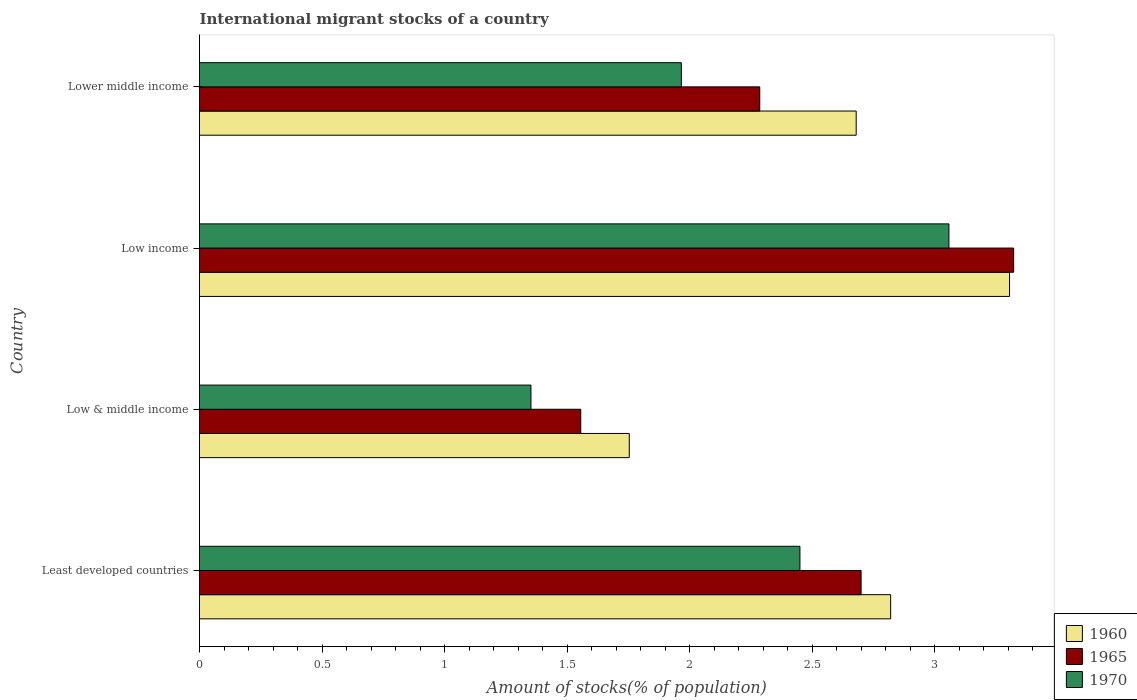How many different coloured bars are there?
Your answer should be very brief. 3. Are the number of bars per tick equal to the number of legend labels?
Your response must be concise. Yes. How many bars are there on the 4th tick from the bottom?
Give a very brief answer. 3. What is the label of the 1st group of bars from the top?
Provide a short and direct response. Lower middle income. What is the amount of stocks in in 1960 in Least developed countries?
Offer a terse response. 2.82. Across all countries, what is the maximum amount of stocks in in 1965?
Make the answer very short. 3.32. Across all countries, what is the minimum amount of stocks in in 1960?
Provide a short and direct response. 1.75. In which country was the amount of stocks in in 1965 maximum?
Provide a short and direct response. Low income. In which country was the amount of stocks in in 1970 minimum?
Your answer should be compact. Low & middle income. What is the total amount of stocks in in 1960 in the graph?
Provide a short and direct response. 10.56. What is the difference between the amount of stocks in in 1965 in Low & middle income and that in Lower middle income?
Offer a very short reply. -0.73. What is the difference between the amount of stocks in in 1960 in Lower middle income and the amount of stocks in in 1965 in Low & middle income?
Offer a terse response. 1.12. What is the average amount of stocks in in 1960 per country?
Offer a terse response. 2.64. What is the difference between the amount of stocks in in 1965 and amount of stocks in in 1970 in Low & middle income?
Provide a succinct answer. 0.2. What is the ratio of the amount of stocks in in 1960 in Low & middle income to that in Lower middle income?
Your answer should be very brief. 0.65. Is the amount of stocks in in 1960 in Low & middle income less than that in Low income?
Your response must be concise. Yes. What is the difference between the highest and the second highest amount of stocks in in 1970?
Your answer should be compact. 0.61. What is the difference between the highest and the lowest amount of stocks in in 1960?
Provide a short and direct response. 1.55. Is the sum of the amount of stocks in in 1970 in Least developed countries and Low & middle income greater than the maximum amount of stocks in in 1965 across all countries?
Provide a short and direct response. Yes. What does the 2nd bar from the top in Least developed countries represents?
Offer a terse response. 1965. What does the 2nd bar from the bottom in Least developed countries represents?
Offer a very short reply. 1965. Is it the case that in every country, the sum of the amount of stocks in in 1965 and amount of stocks in in 1960 is greater than the amount of stocks in in 1970?
Ensure brevity in your answer.  Yes. Are all the bars in the graph horizontal?
Make the answer very short. Yes. How many countries are there in the graph?
Offer a very short reply. 4. What is the difference between two consecutive major ticks on the X-axis?
Your answer should be compact. 0.5. Are the values on the major ticks of X-axis written in scientific E-notation?
Keep it short and to the point. No. Does the graph contain any zero values?
Give a very brief answer. No. Does the graph contain grids?
Keep it short and to the point. No. How are the legend labels stacked?
Your response must be concise. Vertical. What is the title of the graph?
Provide a short and direct response. International migrant stocks of a country. What is the label or title of the X-axis?
Your answer should be very brief. Amount of stocks(% of population). What is the Amount of stocks(% of population) in 1960 in Least developed countries?
Provide a succinct answer. 2.82. What is the Amount of stocks(% of population) in 1965 in Least developed countries?
Provide a short and direct response. 2.7. What is the Amount of stocks(% of population) of 1970 in Least developed countries?
Provide a succinct answer. 2.45. What is the Amount of stocks(% of population) in 1960 in Low & middle income?
Give a very brief answer. 1.75. What is the Amount of stocks(% of population) of 1965 in Low & middle income?
Give a very brief answer. 1.56. What is the Amount of stocks(% of population) in 1970 in Low & middle income?
Your answer should be compact. 1.35. What is the Amount of stocks(% of population) of 1960 in Low income?
Your answer should be very brief. 3.31. What is the Amount of stocks(% of population) in 1965 in Low income?
Keep it short and to the point. 3.32. What is the Amount of stocks(% of population) in 1970 in Low income?
Your answer should be very brief. 3.06. What is the Amount of stocks(% of population) of 1960 in Lower middle income?
Keep it short and to the point. 2.68. What is the Amount of stocks(% of population) of 1965 in Lower middle income?
Ensure brevity in your answer.  2.29. What is the Amount of stocks(% of population) of 1970 in Lower middle income?
Provide a short and direct response. 1.97. Across all countries, what is the maximum Amount of stocks(% of population) in 1960?
Your answer should be very brief. 3.31. Across all countries, what is the maximum Amount of stocks(% of population) of 1965?
Offer a terse response. 3.32. Across all countries, what is the maximum Amount of stocks(% of population) in 1970?
Offer a terse response. 3.06. Across all countries, what is the minimum Amount of stocks(% of population) in 1960?
Give a very brief answer. 1.75. Across all countries, what is the minimum Amount of stocks(% of population) of 1965?
Provide a succinct answer. 1.56. Across all countries, what is the minimum Amount of stocks(% of population) in 1970?
Offer a terse response. 1.35. What is the total Amount of stocks(% of population) in 1960 in the graph?
Offer a terse response. 10.56. What is the total Amount of stocks(% of population) in 1965 in the graph?
Offer a very short reply. 9.86. What is the total Amount of stocks(% of population) in 1970 in the graph?
Give a very brief answer. 8.83. What is the difference between the Amount of stocks(% of population) in 1960 in Least developed countries and that in Low & middle income?
Keep it short and to the point. 1.07. What is the difference between the Amount of stocks(% of population) of 1965 in Least developed countries and that in Low & middle income?
Make the answer very short. 1.14. What is the difference between the Amount of stocks(% of population) in 1970 in Least developed countries and that in Low & middle income?
Give a very brief answer. 1.1. What is the difference between the Amount of stocks(% of population) in 1960 in Least developed countries and that in Low income?
Provide a short and direct response. -0.49. What is the difference between the Amount of stocks(% of population) of 1965 in Least developed countries and that in Low income?
Offer a terse response. -0.62. What is the difference between the Amount of stocks(% of population) in 1970 in Least developed countries and that in Low income?
Your response must be concise. -0.61. What is the difference between the Amount of stocks(% of population) in 1960 in Least developed countries and that in Lower middle income?
Ensure brevity in your answer.  0.14. What is the difference between the Amount of stocks(% of population) of 1965 in Least developed countries and that in Lower middle income?
Offer a terse response. 0.41. What is the difference between the Amount of stocks(% of population) of 1970 in Least developed countries and that in Lower middle income?
Your response must be concise. 0.48. What is the difference between the Amount of stocks(% of population) in 1960 in Low & middle income and that in Low income?
Your response must be concise. -1.55. What is the difference between the Amount of stocks(% of population) of 1965 in Low & middle income and that in Low income?
Give a very brief answer. -1.77. What is the difference between the Amount of stocks(% of population) of 1970 in Low & middle income and that in Low income?
Ensure brevity in your answer.  -1.71. What is the difference between the Amount of stocks(% of population) in 1960 in Low & middle income and that in Lower middle income?
Offer a terse response. -0.93. What is the difference between the Amount of stocks(% of population) in 1965 in Low & middle income and that in Lower middle income?
Provide a short and direct response. -0.73. What is the difference between the Amount of stocks(% of population) of 1970 in Low & middle income and that in Lower middle income?
Your answer should be very brief. -0.61. What is the difference between the Amount of stocks(% of population) of 1960 in Low income and that in Lower middle income?
Your answer should be very brief. 0.63. What is the difference between the Amount of stocks(% of population) of 1965 in Low income and that in Lower middle income?
Keep it short and to the point. 1.04. What is the difference between the Amount of stocks(% of population) of 1970 in Low income and that in Lower middle income?
Your response must be concise. 1.09. What is the difference between the Amount of stocks(% of population) in 1960 in Least developed countries and the Amount of stocks(% of population) in 1965 in Low & middle income?
Provide a succinct answer. 1.26. What is the difference between the Amount of stocks(% of population) in 1960 in Least developed countries and the Amount of stocks(% of population) in 1970 in Low & middle income?
Make the answer very short. 1.47. What is the difference between the Amount of stocks(% of population) in 1965 in Least developed countries and the Amount of stocks(% of population) in 1970 in Low & middle income?
Provide a short and direct response. 1.35. What is the difference between the Amount of stocks(% of population) in 1960 in Least developed countries and the Amount of stocks(% of population) in 1965 in Low income?
Ensure brevity in your answer.  -0.5. What is the difference between the Amount of stocks(% of population) of 1960 in Least developed countries and the Amount of stocks(% of population) of 1970 in Low income?
Give a very brief answer. -0.24. What is the difference between the Amount of stocks(% of population) of 1965 in Least developed countries and the Amount of stocks(% of population) of 1970 in Low income?
Provide a short and direct response. -0.36. What is the difference between the Amount of stocks(% of population) of 1960 in Least developed countries and the Amount of stocks(% of population) of 1965 in Lower middle income?
Provide a short and direct response. 0.53. What is the difference between the Amount of stocks(% of population) in 1960 in Least developed countries and the Amount of stocks(% of population) in 1970 in Lower middle income?
Your answer should be very brief. 0.85. What is the difference between the Amount of stocks(% of population) of 1965 in Least developed countries and the Amount of stocks(% of population) of 1970 in Lower middle income?
Offer a very short reply. 0.73. What is the difference between the Amount of stocks(% of population) of 1960 in Low & middle income and the Amount of stocks(% of population) of 1965 in Low income?
Make the answer very short. -1.57. What is the difference between the Amount of stocks(% of population) of 1960 in Low & middle income and the Amount of stocks(% of population) of 1970 in Low income?
Your answer should be compact. -1.3. What is the difference between the Amount of stocks(% of population) of 1965 in Low & middle income and the Amount of stocks(% of population) of 1970 in Low income?
Your answer should be compact. -1.5. What is the difference between the Amount of stocks(% of population) in 1960 in Low & middle income and the Amount of stocks(% of population) in 1965 in Lower middle income?
Your answer should be very brief. -0.53. What is the difference between the Amount of stocks(% of population) in 1960 in Low & middle income and the Amount of stocks(% of population) in 1970 in Lower middle income?
Give a very brief answer. -0.21. What is the difference between the Amount of stocks(% of population) in 1965 in Low & middle income and the Amount of stocks(% of population) in 1970 in Lower middle income?
Your answer should be compact. -0.41. What is the difference between the Amount of stocks(% of population) in 1960 in Low income and the Amount of stocks(% of population) in 1965 in Lower middle income?
Your answer should be compact. 1.02. What is the difference between the Amount of stocks(% of population) in 1960 in Low income and the Amount of stocks(% of population) in 1970 in Lower middle income?
Give a very brief answer. 1.34. What is the difference between the Amount of stocks(% of population) in 1965 in Low income and the Amount of stocks(% of population) in 1970 in Lower middle income?
Your answer should be compact. 1.36. What is the average Amount of stocks(% of population) of 1960 per country?
Keep it short and to the point. 2.64. What is the average Amount of stocks(% of population) in 1965 per country?
Make the answer very short. 2.47. What is the average Amount of stocks(% of population) in 1970 per country?
Offer a terse response. 2.21. What is the difference between the Amount of stocks(% of population) in 1960 and Amount of stocks(% of population) in 1965 in Least developed countries?
Make the answer very short. 0.12. What is the difference between the Amount of stocks(% of population) in 1960 and Amount of stocks(% of population) in 1970 in Least developed countries?
Your answer should be very brief. 0.37. What is the difference between the Amount of stocks(% of population) in 1965 and Amount of stocks(% of population) in 1970 in Least developed countries?
Offer a very short reply. 0.25. What is the difference between the Amount of stocks(% of population) of 1960 and Amount of stocks(% of population) of 1965 in Low & middle income?
Offer a very short reply. 0.2. What is the difference between the Amount of stocks(% of population) of 1960 and Amount of stocks(% of population) of 1970 in Low & middle income?
Your answer should be compact. 0.4. What is the difference between the Amount of stocks(% of population) in 1965 and Amount of stocks(% of population) in 1970 in Low & middle income?
Your answer should be very brief. 0.2. What is the difference between the Amount of stocks(% of population) of 1960 and Amount of stocks(% of population) of 1965 in Low income?
Your answer should be very brief. -0.02. What is the difference between the Amount of stocks(% of population) in 1960 and Amount of stocks(% of population) in 1970 in Low income?
Offer a terse response. 0.25. What is the difference between the Amount of stocks(% of population) of 1965 and Amount of stocks(% of population) of 1970 in Low income?
Offer a very short reply. 0.26. What is the difference between the Amount of stocks(% of population) of 1960 and Amount of stocks(% of population) of 1965 in Lower middle income?
Offer a terse response. 0.39. What is the difference between the Amount of stocks(% of population) in 1960 and Amount of stocks(% of population) in 1970 in Lower middle income?
Ensure brevity in your answer.  0.71. What is the difference between the Amount of stocks(% of population) in 1965 and Amount of stocks(% of population) in 1970 in Lower middle income?
Offer a terse response. 0.32. What is the ratio of the Amount of stocks(% of population) of 1960 in Least developed countries to that in Low & middle income?
Your answer should be compact. 1.61. What is the ratio of the Amount of stocks(% of population) in 1965 in Least developed countries to that in Low & middle income?
Ensure brevity in your answer.  1.74. What is the ratio of the Amount of stocks(% of population) in 1970 in Least developed countries to that in Low & middle income?
Make the answer very short. 1.81. What is the ratio of the Amount of stocks(% of population) in 1960 in Least developed countries to that in Low income?
Ensure brevity in your answer.  0.85. What is the ratio of the Amount of stocks(% of population) in 1965 in Least developed countries to that in Low income?
Offer a terse response. 0.81. What is the ratio of the Amount of stocks(% of population) of 1970 in Least developed countries to that in Low income?
Keep it short and to the point. 0.8. What is the ratio of the Amount of stocks(% of population) in 1960 in Least developed countries to that in Lower middle income?
Offer a very short reply. 1.05. What is the ratio of the Amount of stocks(% of population) in 1965 in Least developed countries to that in Lower middle income?
Ensure brevity in your answer.  1.18. What is the ratio of the Amount of stocks(% of population) of 1970 in Least developed countries to that in Lower middle income?
Offer a very short reply. 1.25. What is the ratio of the Amount of stocks(% of population) in 1960 in Low & middle income to that in Low income?
Ensure brevity in your answer.  0.53. What is the ratio of the Amount of stocks(% of population) of 1965 in Low & middle income to that in Low income?
Keep it short and to the point. 0.47. What is the ratio of the Amount of stocks(% of population) of 1970 in Low & middle income to that in Low income?
Keep it short and to the point. 0.44. What is the ratio of the Amount of stocks(% of population) of 1960 in Low & middle income to that in Lower middle income?
Your answer should be compact. 0.65. What is the ratio of the Amount of stocks(% of population) in 1965 in Low & middle income to that in Lower middle income?
Provide a short and direct response. 0.68. What is the ratio of the Amount of stocks(% of population) of 1970 in Low & middle income to that in Lower middle income?
Ensure brevity in your answer.  0.69. What is the ratio of the Amount of stocks(% of population) in 1960 in Low income to that in Lower middle income?
Keep it short and to the point. 1.23. What is the ratio of the Amount of stocks(% of population) in 1965 in Low income to that in Lower middle income?
Your response must be concise. 1.45. What is the ratio of the Amount of stocks(% of population) of 1970 in Low income to that in Lower middle income?
Your response must be concise. 1.56. What is the difference between the highest and the second highest Amount of stocks(% of population) in 1960?
Your answer should be compact. 0.49. What is the difference between the highest and the second highest Amount of stocks(% of population) of 1965?
Keep it short and to the point. 0.62. What is the difference between the highest and the second highest Amount of stocks(% of population) in 1970?
Keep it short and to the point. 0.61. What is the difference between the highest and the lowest Amount of stocks(% of population) of 1960?
Provide a short and direct response. 1.55. What is the difference between the highest and the lowest Amount of stocks(% of population) of 1965?
Make the answer very short. 1.77. What is the difference between the highest and the lowest Amount of stocks(% of population) of 1970?
Your answer should be compact. 1.71. 